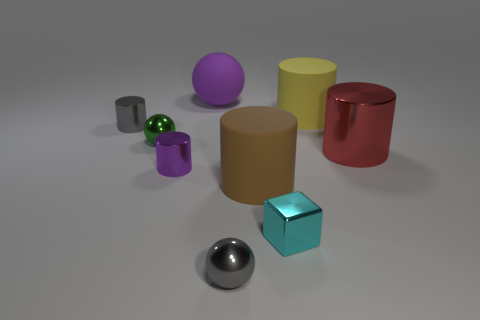Subtract 2 cylinders. How many cylinders are left? 3 Subtract all red cylinders. How many cylinders are left? 4 Subtract all cyan cylinders. Subtract all green spheres. How many cylinders are left? 5 Add 1 small purple things. How many objects exist? 10 Subtract all cylinders. How many objects are left? 4 Add 5 tiny cyan cubes. How many tiny cyan cubes are left? 6 Add 5 blue shiny objects. How many blue shiny objects exist? 5 Subtract 0 blue cylinders. How many objects are left? 9 Subtract all cyan objects. Subtract all cyan metallic things. How many objects are left? 7 